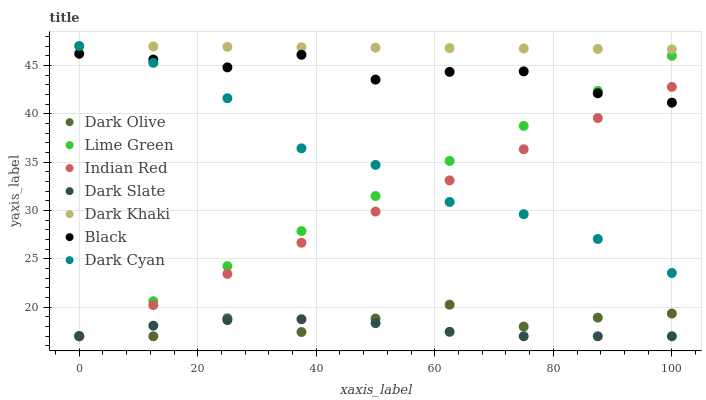Does Dark Slate have the minimum area under the curve?
Answer yes or no. Yes. Does Dark Khaki have the maximum area under the curve?
Answer yes or no. Yes. Does Dark Khaki have the minimum area under the curve?
Answer yes or no. No. Does Dark Slate have the maximum area under the curve?
Answer yes or no. No. Is Dark Khaki the smoothest?
Answer yes or no. Yes. Is Dark Olive the roughest?
Answer yes or no. Yes. Is Dark Slate the smoothest?
Answer yes or no. No. Is Dark Slate the roughest?
Answer yes or no. No. Does Dark Olive have the lowest value?
Answer yes or no. Yes. Does Dark Khaki have the lowest value?
Answer yes or no. No. Does Dark Cyan have the highest value?
Answer yes or no. Yes. Does Dark Slate have the highest value?
Answer yes or no. No. Is Dark Olive less than Black?
Answer yes or no. Yes. Is Dark Khaki greater than Lime Green?
Answer yes or no. Yes. Does Dark Cyan intersect Black?
Answer yes or no. Yes. Is Dark Cyan less than Black?
Answer yes or no. No. Is Dark Cyan greater than Black?
Answer yes or no. No. Does Dark Olive intersect Black?
Answer yes or no. No. 